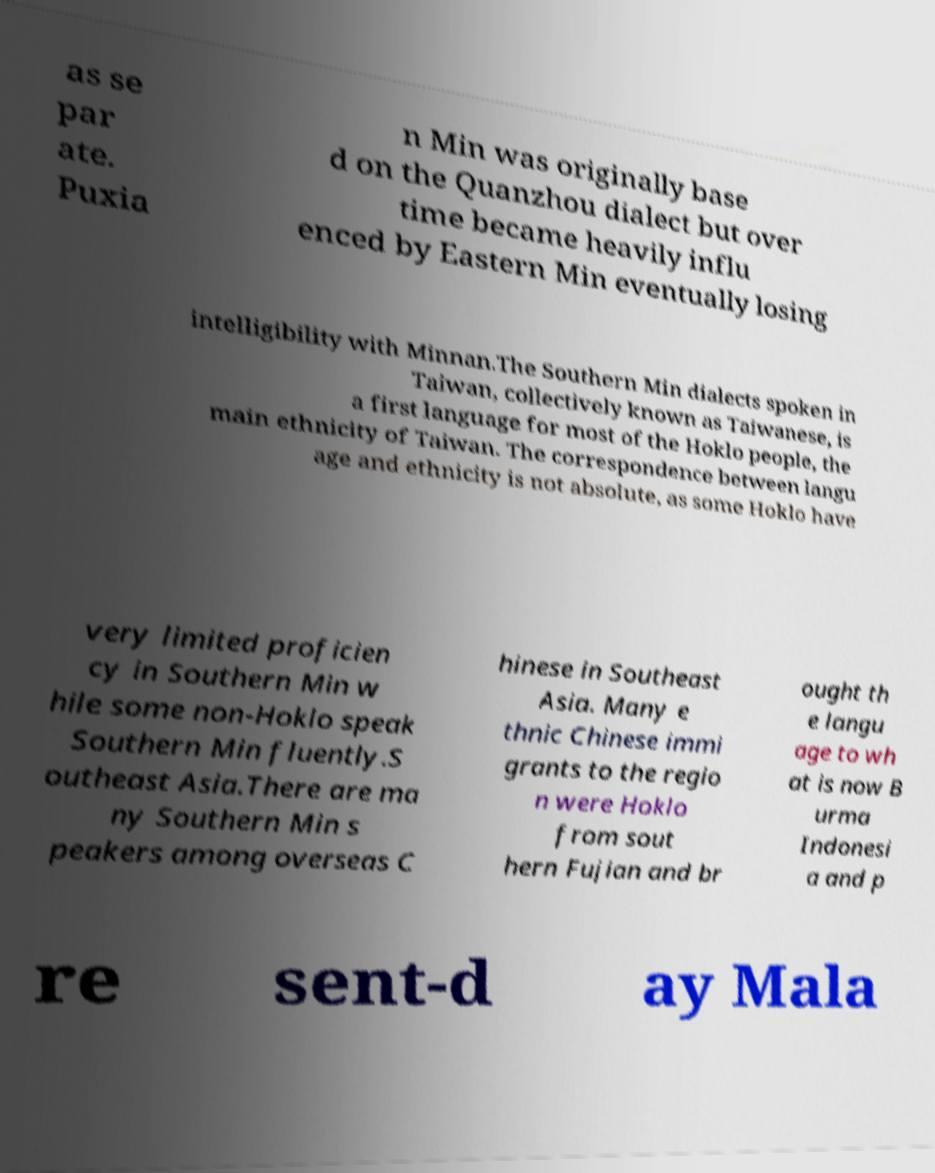Can you read and provide the text displayed in the image?This photo seems to have some interesting text. Can you extract and type it out for me? as se par ate. Puxia n Min was originally base d on the Quanzhou dialect but over time became heavily influ enced by Eastern Min eventually losing intelligibility with Minnan.The Southern Min dialects spoken in Taiwan, collectively known as Taiwanese, is a first language for most of the Hoklo people, the main ethnicity of Taiwan. The correspondence between langu age and ethnicity is not absolute, as some Hoklo have very limited proficien cy in Southern Min w hile some non-Hoklo speak Southern Min fluently.S outheast Asia.There are ma ny Southern Min s peakers among overseas C hinese in Southeast Asia. Many e thnic Chinese immi grants to the regio n were Hoklo from sout hern Fujian and br ought th e langu age to wh at is now B urma Indonesi a and p re sent-d ay Mala 